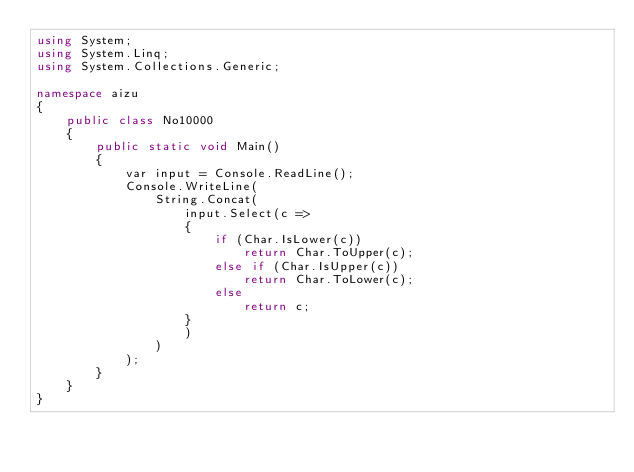<code> <loc_0><loc_0><loc_500><loc_500><_C#_>using System;
using System.Linq;
using System.Collections.Generic;

namespace aizu
{
    public class No10000
    {
        public static void Main()
        {
            var input = Console.ReadLine();
            Console.WriteLine(
                String.Concat(
                    input.Select(c =>
                    {
                        if (Char.IsLower(c))
                            return Char.ToUpper(c);
                        else if (Char.IsUpper(c))
                            return Char.ToLower(c);
                        else
                            return c;
                    }
                    )
                )
            );
        }
    }
}</code> 